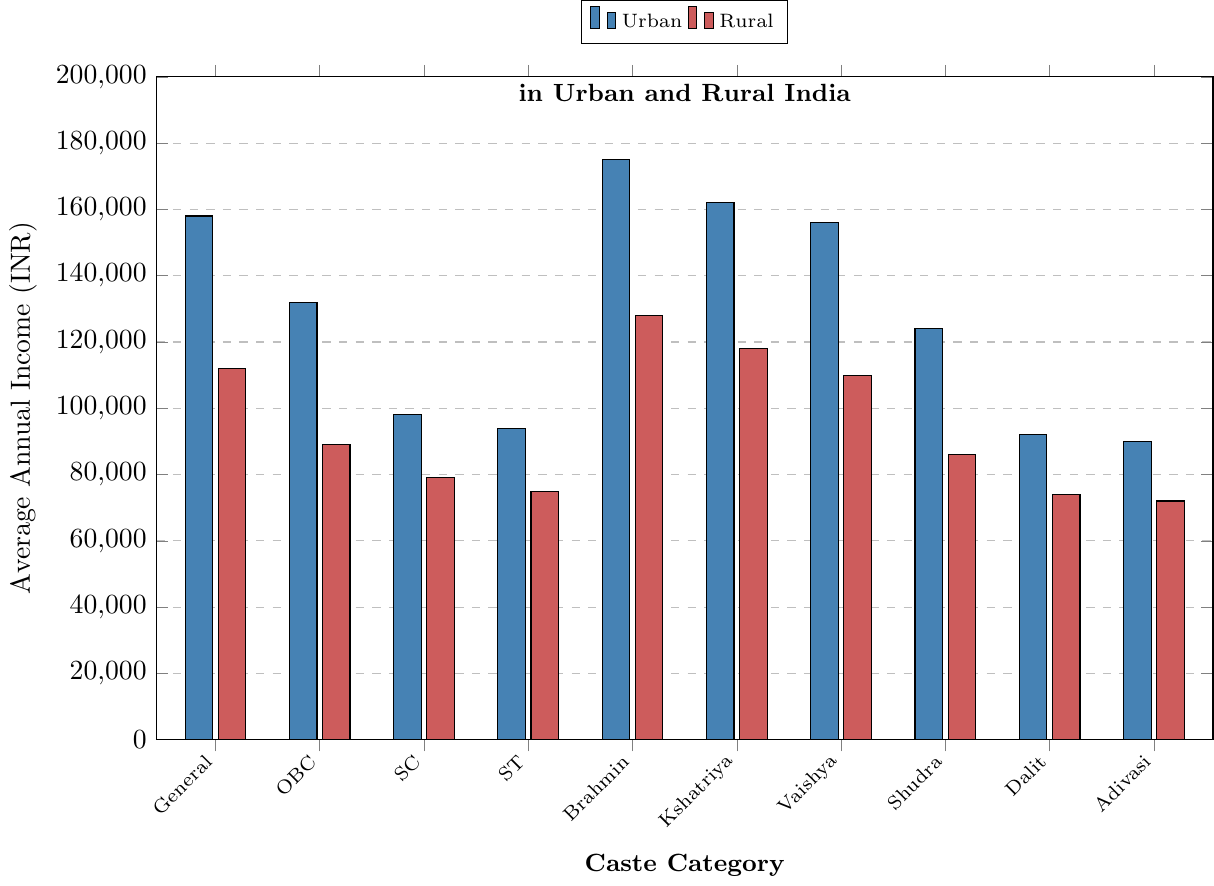Which caste category has the highest average annual income in urban areas? The highest bar in the urban category represents the Brahmin caste, indicating they have the highest average annual income in urban areas.
Answer: Brahmin Which caste category has the lowest average annual income in rural areas? The lowest bar in the rural category represents the Adivasi caste, showing they have the lowest average annual income in rural areas.
Answer: Adivasi What is the income disparity between urban and rural areas for the General caste? The urban income for the General caste is 158,000 INR and the rural income is 112,000 INR. The disparity is calculated by subtracting the rural income from the urban income: 158,000 - 112,000 = 46,000 INR.
Answer: 46,000 INR How does the average annual income of the Shudra caste in urban areas compare to rural areas? The urban income for the Shudra caste is 124,000 INR, and the rural income is 86,000 INR. The urban income is significantly higher.
Answer: Higher Which caste category has a smaller difference between urban and rural incomes, SC or ST? For the SC category, the difference is 98,000 - 79,000 = 19,000 INR. For the ST category, the difference is 94,000 - 75,000 = 19,000 INR. Both categories have the same income difference.
Answer: Same What is the total average annual income for the Kshatriya caste combining both urban and rural areas? The urban income for Kshatriya is 162,000 INR, and the rural income is 118,000 INR. The total is 162,000 + 118,000 = 280,000 INR.
Answer: 280,000 INR Across all caste categories, which one experiences the largest income disparity between urban and rural areas? Comparing the disparity for each caste, Brahmin has the largest difference: 175,000 - 128,000 = 47,000 INR.
Answer: Brahmin What is the average annual income of Vaishya caste in urban areas relative to the General caste category in rural areas? The Vaishya urban income is 156,000 INR, and the General rural income is 112,000 INR, meaning Vaishya urban income is higher.
Answer: Higher 